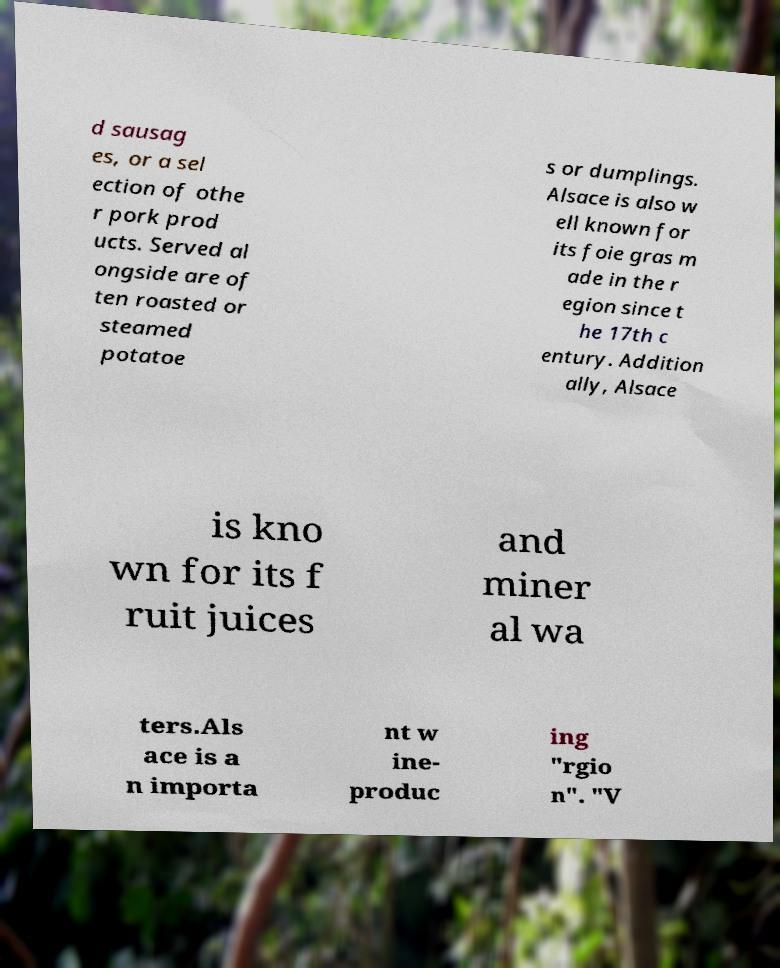There's text embedded in this image that I need extracted. Can you transcribe it verbatim? d sausag es, or a sel ection of othe r pork prod ucts. Served al ongside are of ten roasted or steamed potatoe s or dumplings. Alsace is also w ell known for its foie gras m ade in the r egion since t he 17th c entury. Addition ally, Alsace is kno wn for its f ruit juices and miner al wa ters.Als ace is a n importa nt w ine- produc ing "rgio n". "V 